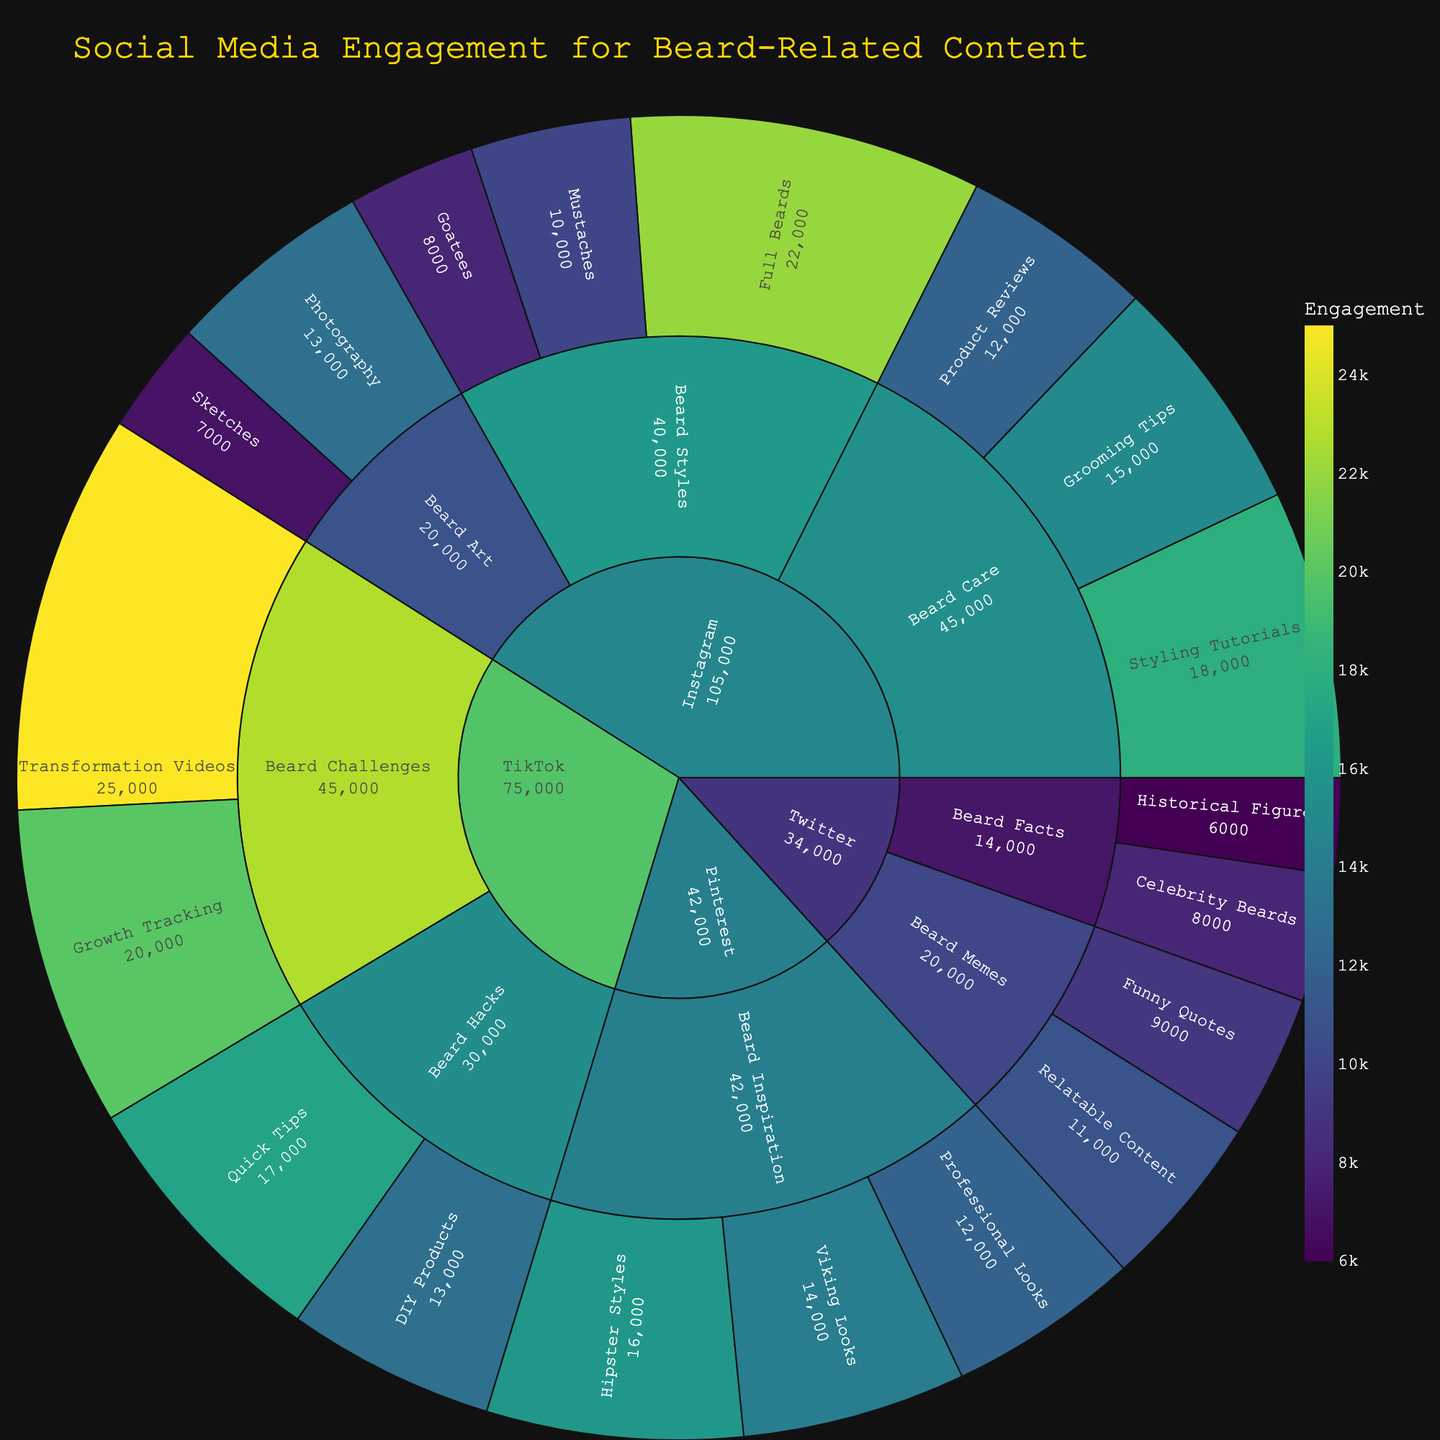What is the title of the Sunburst Plot? The title of the Sunburst Plot is typically displayed prominently at the top of the plot. It summarizes the content and focus of the visual representation.
Answer: Social Media Engagement for Beard-Related Content Which subcategory under Instagram has the highest engagement? To determine the subcategory with the highest engagement under Instagram, locate the Instagram segment and then compare the values of each subcategory within it.
Answer: Full Beards What is the total engagement for Instagram Beard Care content? To find the total engagement for Instagram Beard Care content, sum the engagement values of all subcategories under Beard Care on Instagram. This requires adding 15,000, 12,000, and 18,000.
Answer: 45,000 How does the engagement for TikTok Beard Challenges compare to TikTok Beard Hacks? First, identify the engagement values for TikTok Beard Challenges and TikTok Beard Hacks. Sum up the engagements under each category: Beard Challenges (20,000 + 25,000) and Beard Hacks (17,000 + 13,000). Then compare the two sums.
Answer: Beard Challenges is higher Which platform has the highest engagement for bearded content overall? Locate and sum up the total engagement for each platform by adding the engagement values of all its subcategories. Compare the total engagements for each platform to find the one with the highest value.
Answer: Instagram What is the engagement difference between Instagram Beard Styles and Pinterest Beard Inspiration? Identify the engagement values for all subcategories under Instagram Beard Styles and Pinterest Beard Inspiration. Sum them up and calculate the difference between the two totals.
Answer: 2,000 Which platform contains the subcategory with the lowest engagement? Identify and compare the engagement values for all subcategories across different platforms. The platform with the smallest value among its subcategories indicates the platform with the lowest engagement for a specific subcategory.
Answer: Twitter How many subcategories are under each platform? Count the number of distinct subcategories directly under each platform.
Answer: Instagram: 8, Twitter: 4, Pinterest: 3, TikTok: 4 What is the engagement for bearded sketches on Instagram? Locate the subcategory 'Sketches' under the 'Beard Art' segment within Instagram and note its engagement value.
Answer: 7,000 Which TikTok subcategory has the highest engagement, and what is it? Compare the engagement values of all subcategories under TikTok. The one with the highest value stands out as the subcategory with the highest engagement.
Answer: Transformation Videos with 25,000 